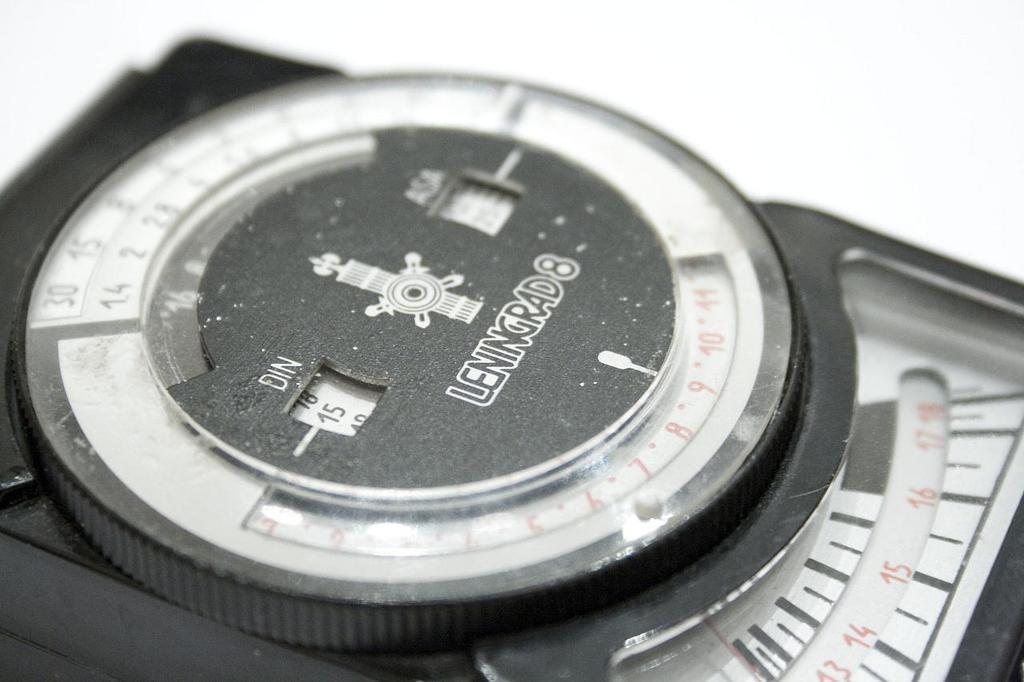<image>
Relay a brief, clear account of the picture shown. A Leningrad mechanical device with numbers around the center. 